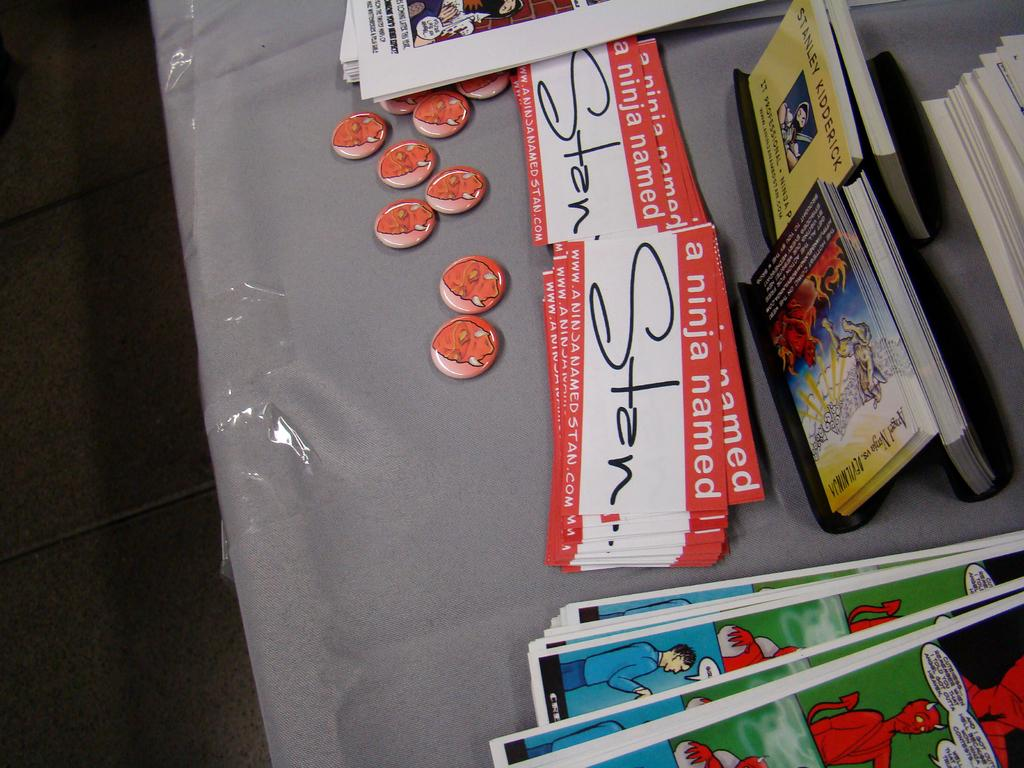<image>
Offer a succinct explanation of the picture presented. A stack of novelty nametags for someone named Stan 